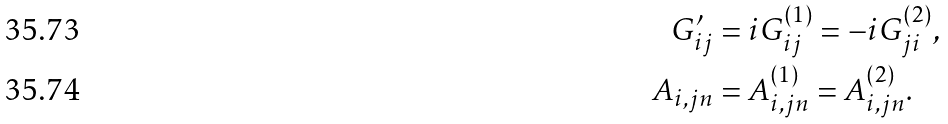<formula> <loc_0><loc_0><loc_500><loc_500>G ^ { \prime } _ { i j } & = i G _ { i j } ^ { ( 1 ) } = - i G _ { j i } ^ { ( 2 ) } , \\ A _ { i , j n } & = A _ { i , j n } ^ { ( 1 ) } = A _ { i , j n } ^ { ( 2 ) } .</formula> 